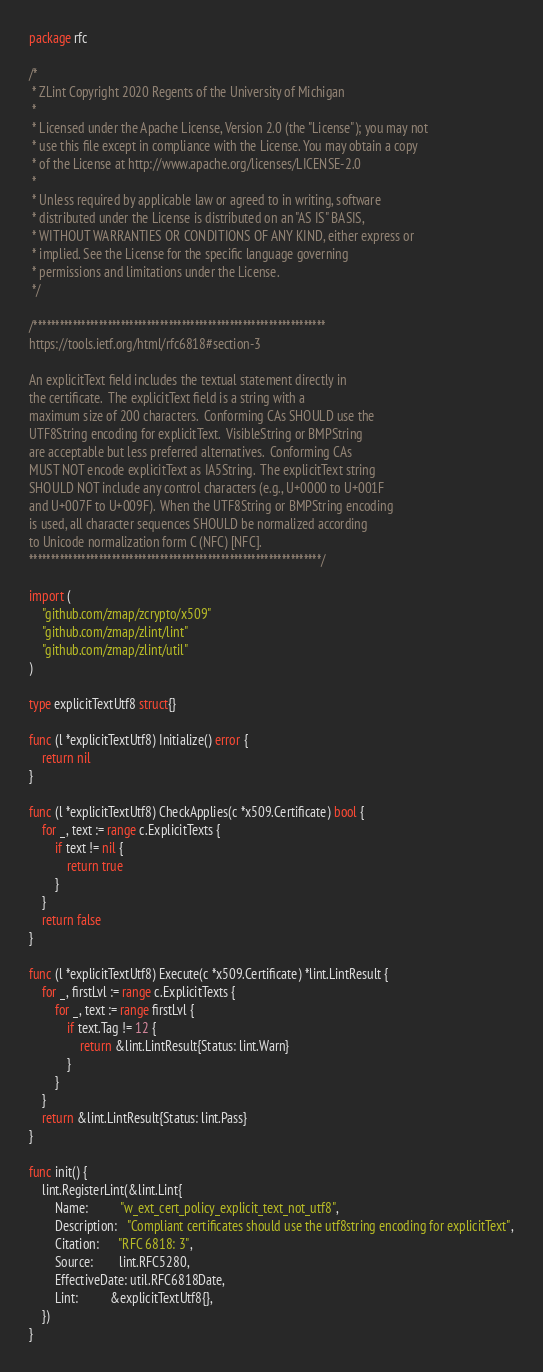Convert code to text. <code><loc_0><loc_0><loc_500><loc_500><_Go_>package rfc

/*
 * ZLint Copyright 2020 Regents of the University of Michigan
 *
 * Licensed under the Apache License, Version 2.0 (the "License"); you may not
 * use this file except in compliance with the License. You may obtain a copy
 * of the License at http://www.apache.org/licenses/LICENSE-2.0
 *
 * Unless required by applicable law or agreed to in writing, software
 * distributed under the License is distributed on an "AS IS" BASIS,
 * WITHOUT WARRANTIES OR CONDITIONS OF ANY KIND, either express or
 * implied. See the License for the specific language governing
 * permissions and limitations under the License.
 */

/*******************************************************************
https://tools.ietf.org/html/rfc6818#section-3

An explicitText field includes the textual statement directly in
the certificate.  The explicitText field is a string with a
maximum size of 200 characters.  Conforming CAs SHOULD use the
UTF8String encoding for explicitText.  VisibleString or BMPString
are acceptable but less preferred alternatives.  Conforming CAs
MUST NOT encode explicitText as IA5String.  The explicitText string
SHOULD NOT include any control characters (e.g., U+0000 to U+001F
and U+007F to U+009F).  When the UTF8String or BMPString encoding
is used, all character sequences SHOULD be normalized according
to Unicode normalization form C (NFC) [NFC].
*******************************************************************/

import (
	"github.com/zmap/zcrypto/x509"
	"github.com/zmap/zlint/lint"
	"github.com/zmap/zlint/util"
)

type explicitTextUtf8 struct{}

func (l *explicitTextUtf8) Initialize() error {
	return nil
}

func (l *explicitTextUtf8) CheckApplies(c *x509.Certificate) bool {
	for _, text := range c.ExplicitTexts {
		if text != nil {
			return true
		}
	}
	return false
}

func (l *explicitTextUtf8) Execute(c *x509.Certificate) *lint.LintResult {
	for _, firstLvl := range c.ExplicitTexts {
		for _, text := range firstLvl {
			if text.Tag != 12 {
				return &lint.LintResult{Status: lint.Warn}
			}
		}
	}
	return &lint.LintResult{Status: lint.Pass}
}

func init() {
	lint.RegisterLint(&lint.Lint{
		Name:          "w_ext_cert_policy_explicit_text_not_utf8",
		Description:   "Compliant certificates should use the utf8string encoding for explicitText",
		Citation:      "RFC 6818: 3",
		Source:        lint.RFC5280,
		EffectiveDate: util.RFC6818Date,
		Lint:          &explicitTextUtf8{},
	})
}
</code> 